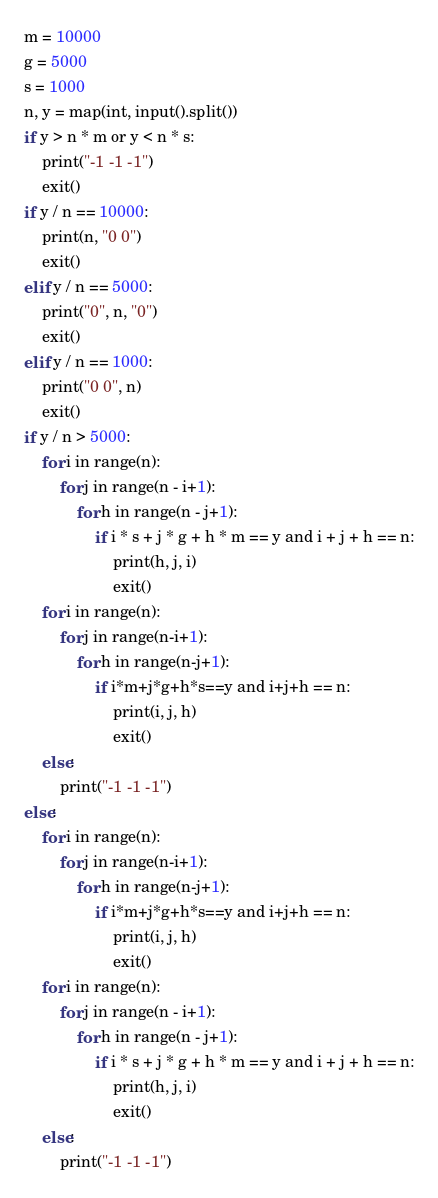<code> <loc_0><loc_0><loc_500><loc_500><_Python_>m = 10000
g = 5000
s = 1000
n, y = map(int, input().split())
if y > n * m or y < n * s:
    print("-1 -1 -1")
    exit()
if y / n == 10000:
    print(n, "0 0")
    exit()
elif y / n == 5000:
    print("0", n, "0")
    exit()
elif y / n == 1000:
    print("0 0", n)
    exit()
if y / n > 5000:
    for i in range(n):
        for j in range(n - i+1):
            for h in range(n - j+1):
                if i * s + j * g + h * m == y and i + j + h == n:
                    print(h, j, i)
                    exit()
    for i in range(n):
        for j in range(n-i+1):
            for h in range(n-j+1):
                if i*m+j*g+h*s==y and i+j+h == n:
                    print(i, j, h)
                    exit()
    else:
        print("-1 -1 -1")
else:
    for i in range(n):
        for j in range(n-i+1):
            for h in range(n-j+1):
                if i*m+j*g+h*s==y and i+j+h == n:
                    print(i, j, h)
                    exit()
    for i in range(n):
        for j in range(n - i+1):
            for h in range(n - j+1):
                if i * s + j * g + h * m == y and i + j + h == n:
                    print(h, j, i)
                    exit()
    else:
        print("-1 -1 -1")</code> 